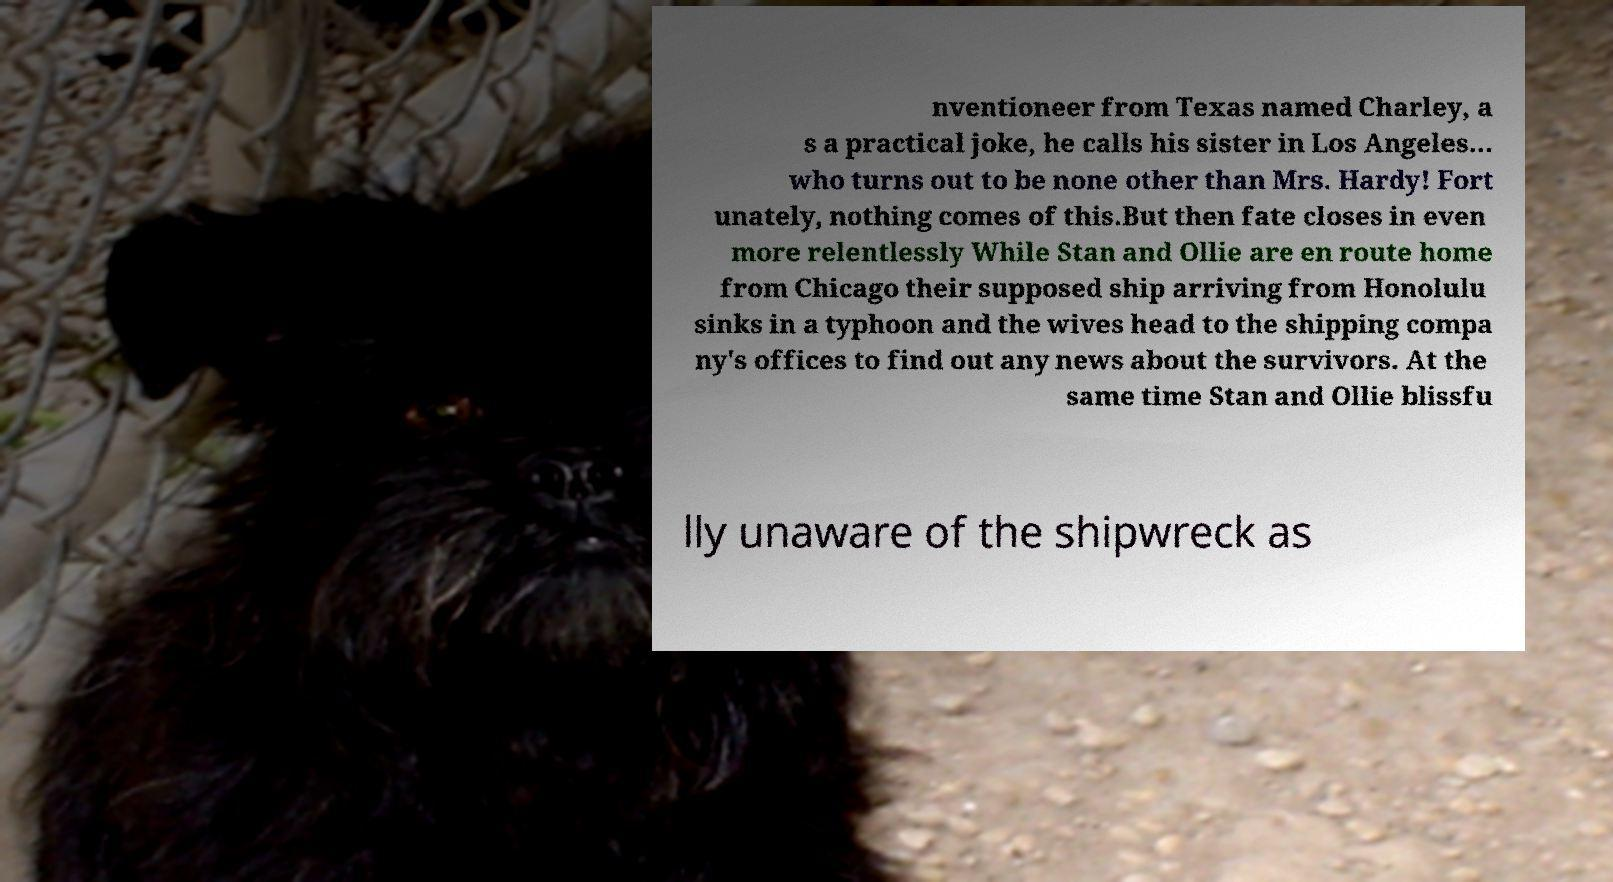I need the written content from this picture converted into text. Can you do that? nventioneer from Texas named Charley, a s a practical joke, he calls his sister in Los Angeles... who turns out to be none other than Mrs. Hardy! Fort unately, nothing comes of this.But then fate closes in even more relentlessly While Stan and Ollie are en route home from Chicago their supposed ship arriving from Honolulu sinks in a typhoon and the wives head to the shipping compa ny's offices to find out any news about the survivors. At the same time Stan and Ollie blissfu lly unaware of the shipwreck as 